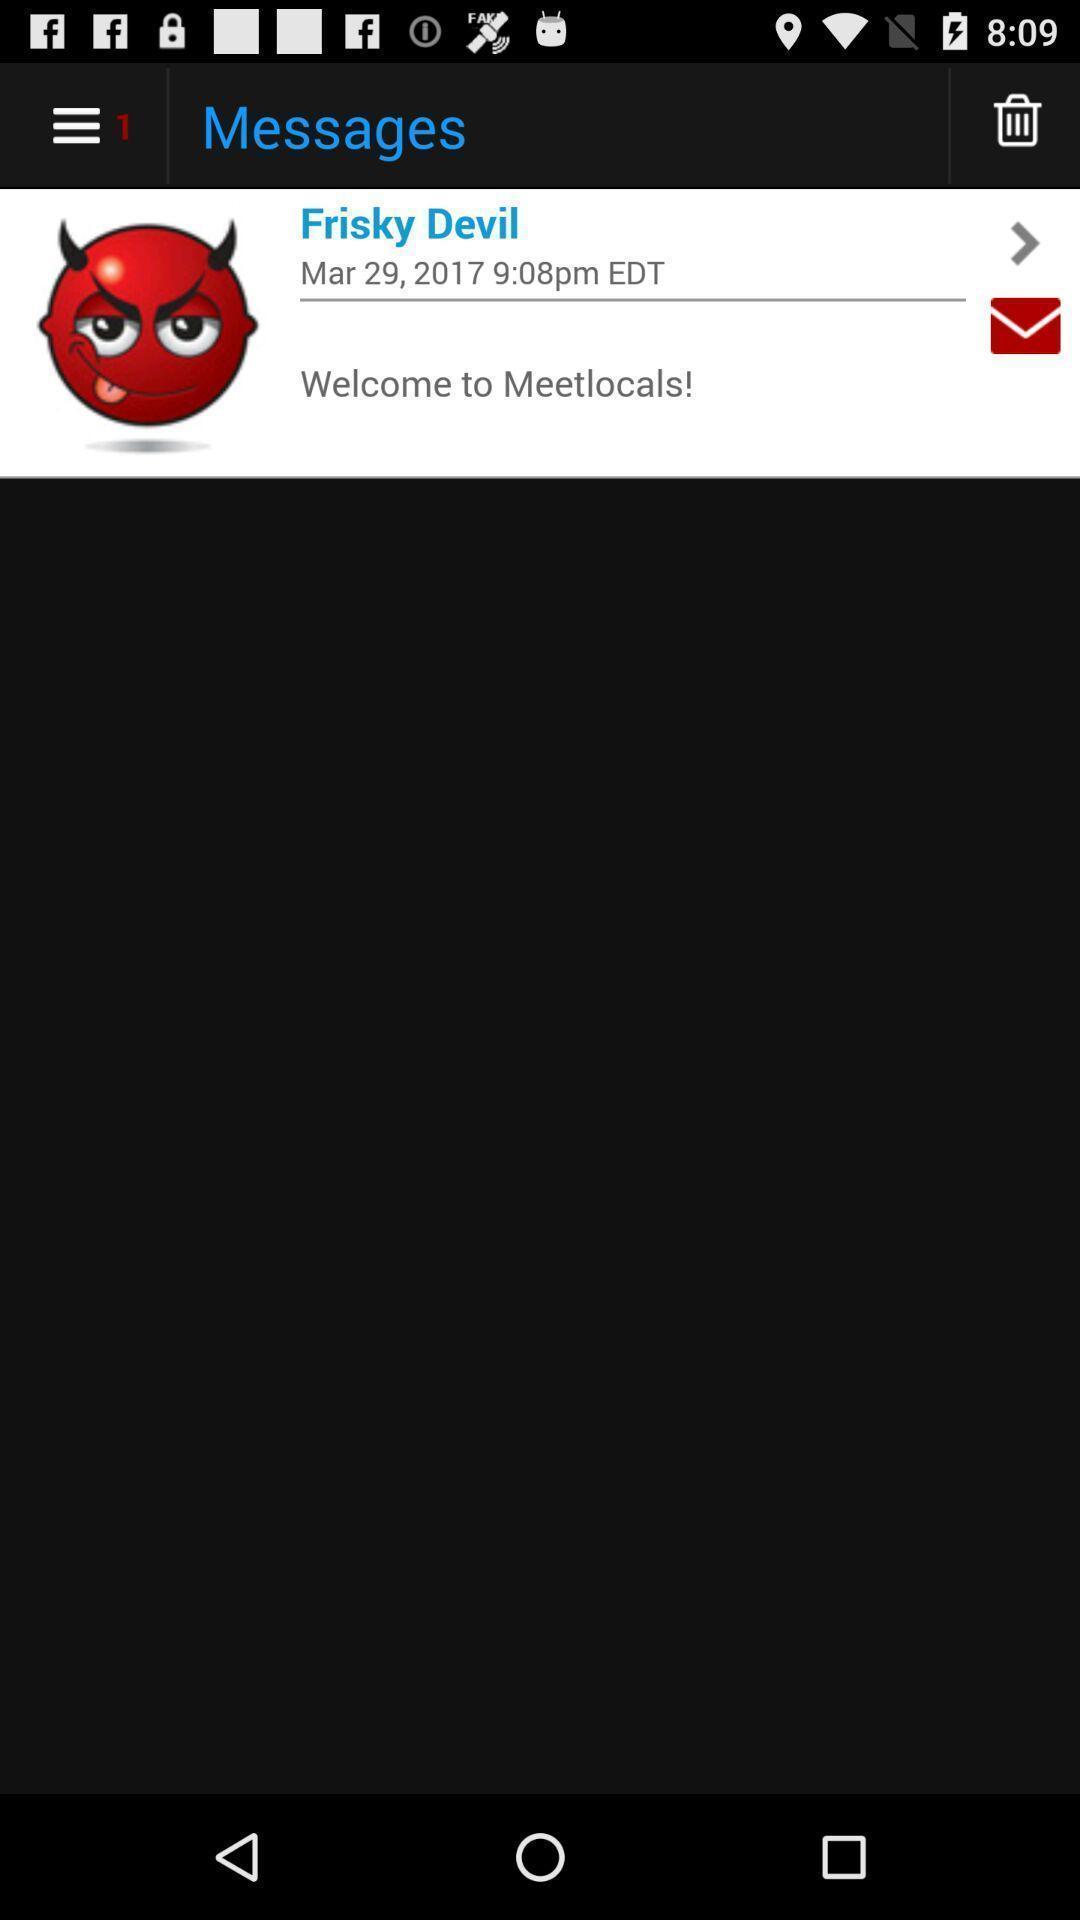Describe the key features of this screenshot. Page showing messages. 